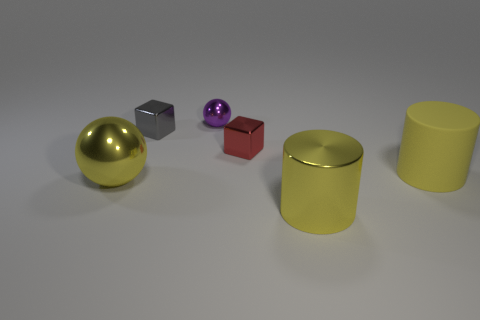Add 2 big brown metal cubes. How many objects exist? 8 Subtract all blocks. How many objects are left? 4 Subtract 0 blue cylinders. How many objects are left? 6 Subtract all small gray shiny spheres. Subtract all big metallic cylinders. How many objects are left? 5 Add 1 tiny cubes. How many tiny cubes are left? 3 Add 5 big yellow matte objects. How many big yellow matte objects exist? 6 